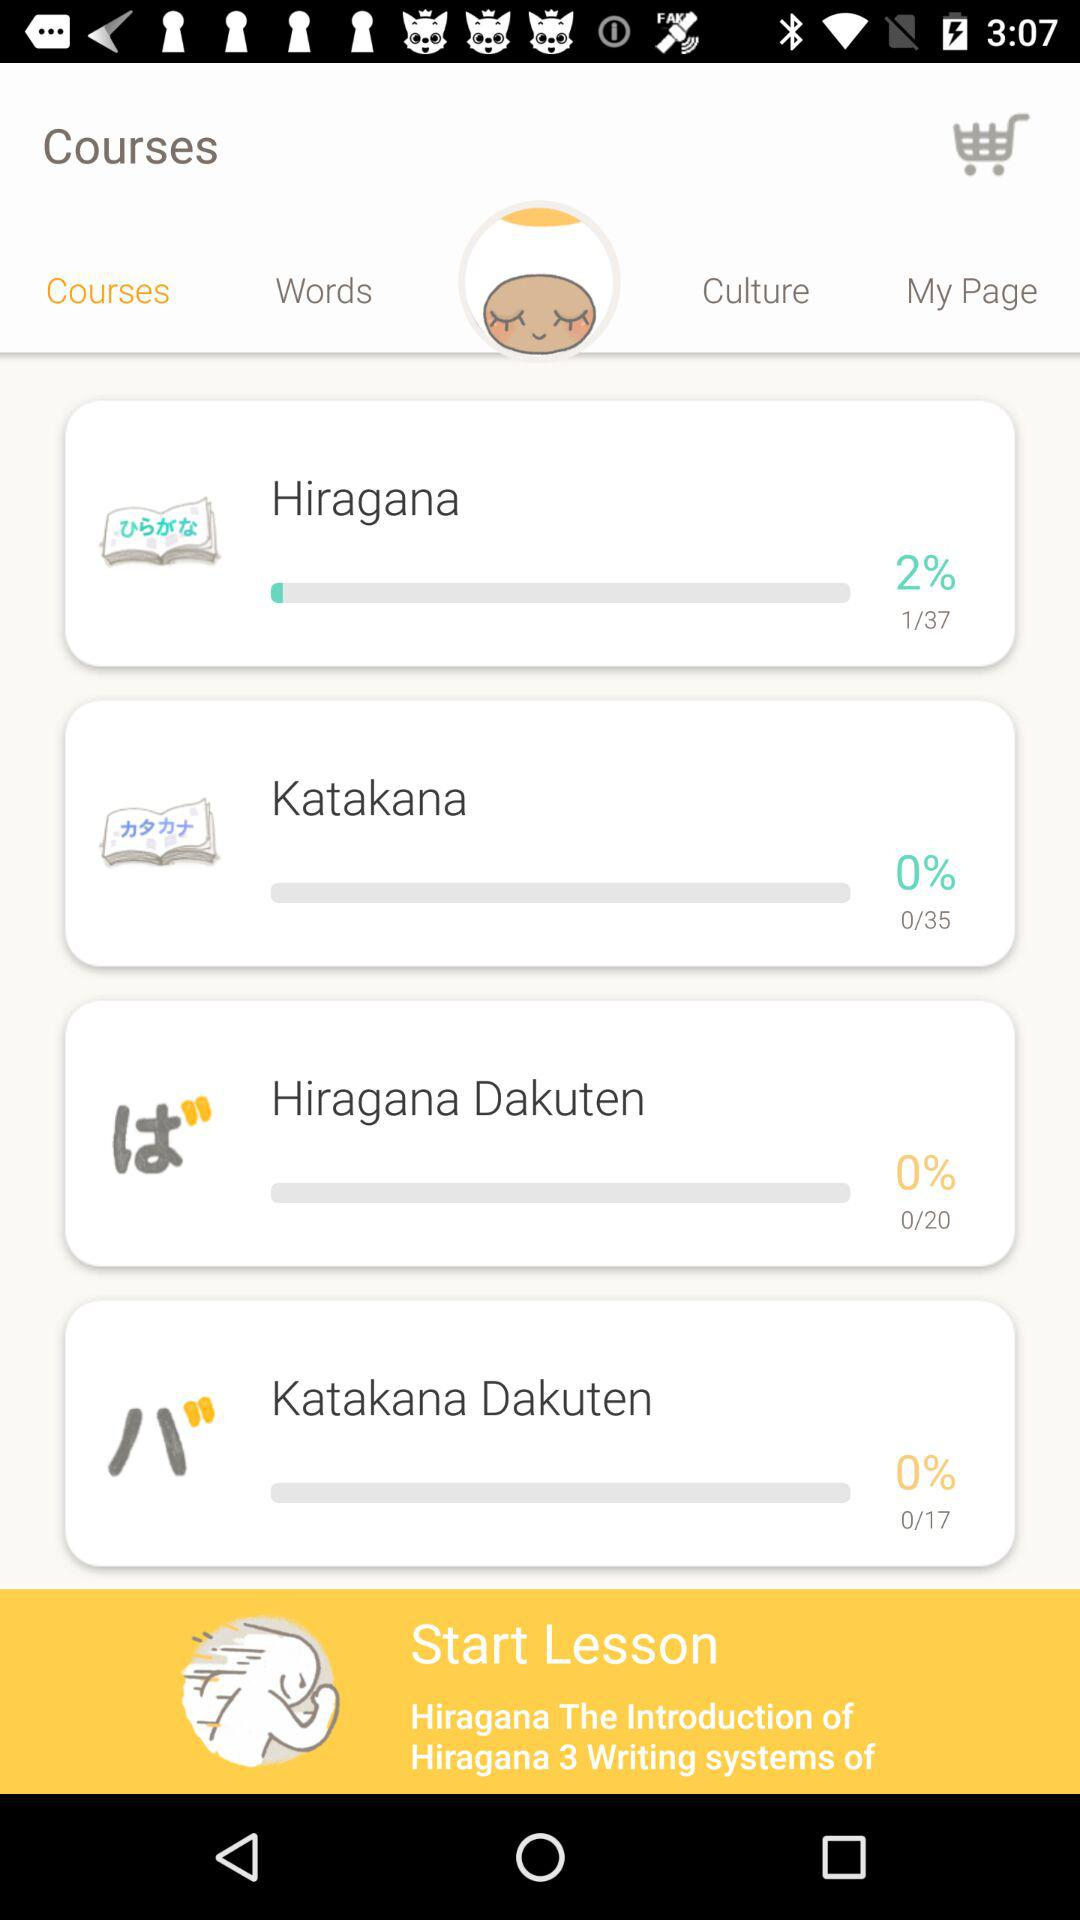I am at which page of "Hiragana" course? You are on page 1. 